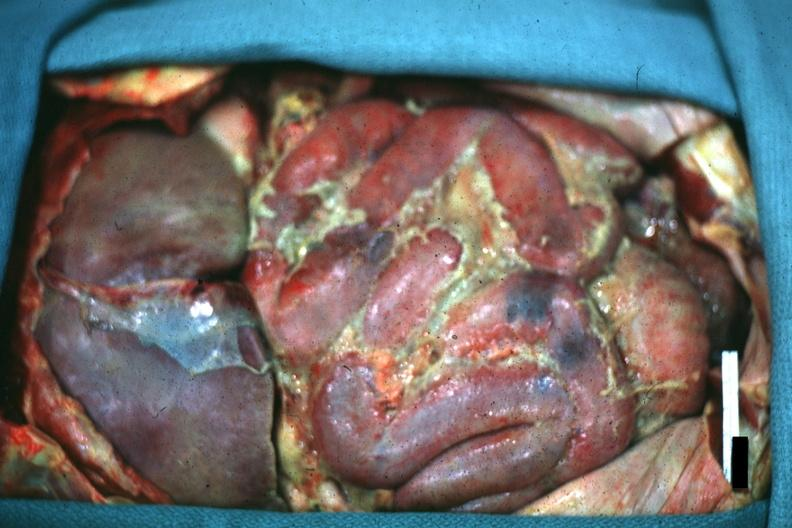what is present?
Answer the question using a single word or phrase. Acute peritonitis 